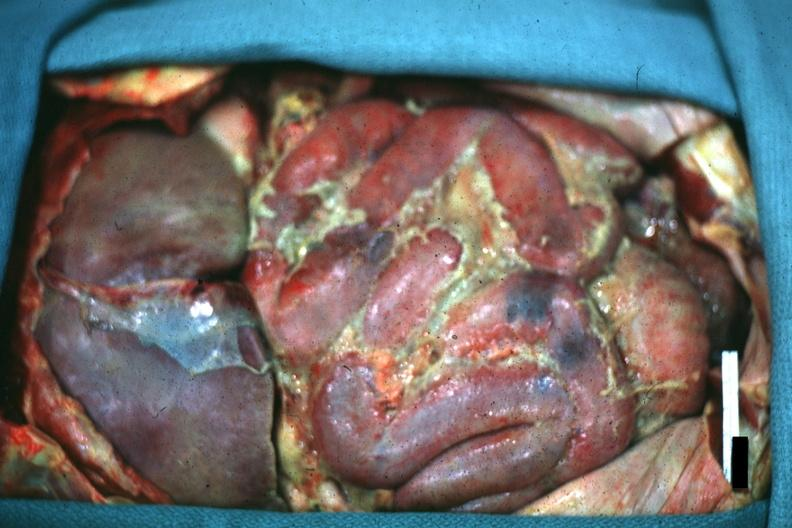what is present?
Answer the question using a single word or phrase. Acute peritonitis 